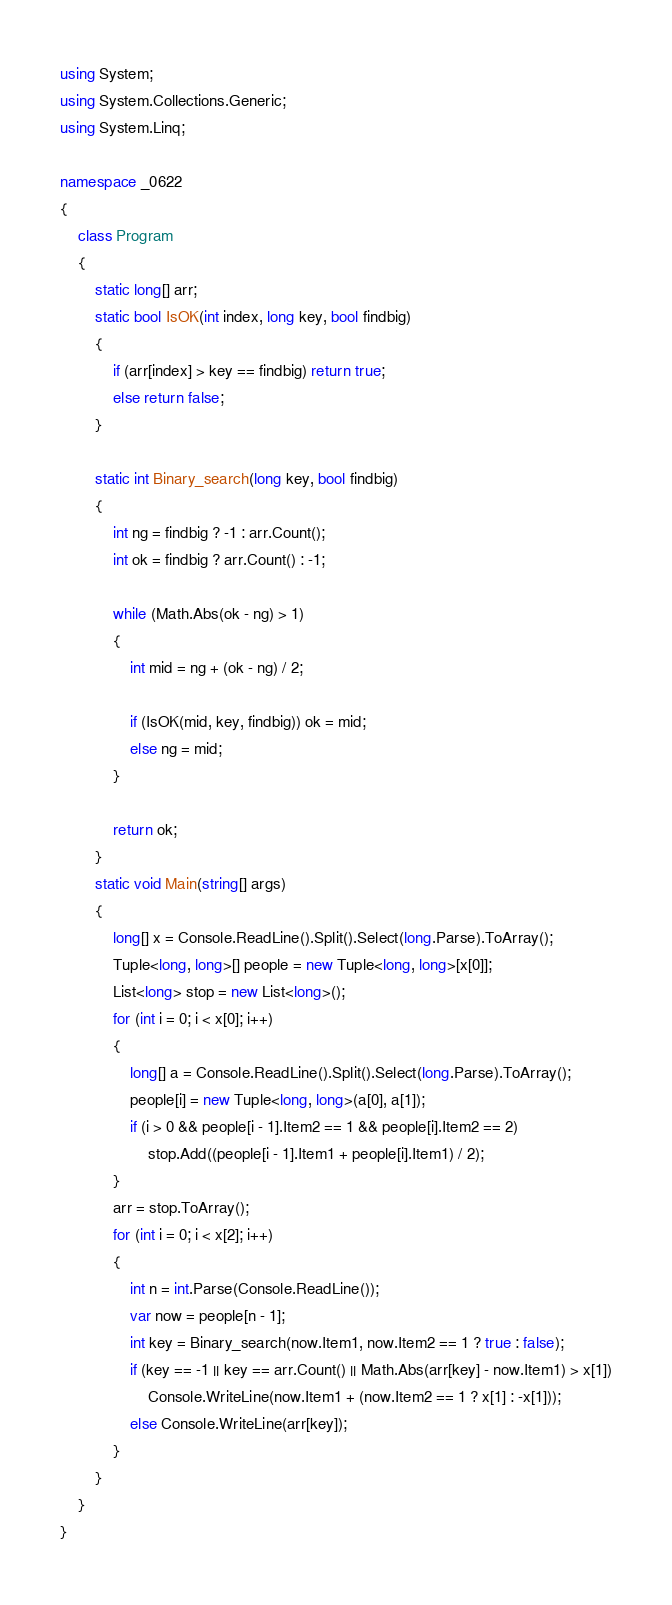Convert code to text. <code><loc_0><loc_0><loc_500><loc_500><_C#_>using System;
using System.Collections.Generic;
using System.Linq;

namespace _0622
{
	class Program
	{
		static long[] arr;
		static bool IsOK(int index, long key, bool findbig)
		{
			if (arr[index] > key == findbig) return true;
			else return false;
		}

		static int Binary_search(long key, bool findbig)
		{
			int ng = findbig ? -1 : arr.Count();
			int ok = findbig ? arr.Count() : -1;

			while (Math.Abs(ok - ng) > 1)
			{
				int mid = ng + (ok - ng) / 2;

				if (IsOK(mid, key, findbig)) ok = mid;
				else ng = mid;
			}

			return ok;
		}
		static void Main(string[] args)
		{
			long[] x = Console.ReadLine().Split().Select(long.Parse).ToArray();
			Tuple<long, long>[] people = new Tuple<long, long>[x[0]];
			List<long> stop = new List<long>();
			for (int i = 0; i < x[0]; i++)
			{
				long[] a = Console.ReadLine().Split().Select(long.Parse).ToArray();
				people[i] = new Tuple<long, long>(a[0], a[1]);
				if (i > 0 && people[i - 1].Item2 == 1 && people[i].Item2 == 2)
					stop.Add((people[i - 1].Item1 + people[i].Item1) / 2);
			}
			arr = stop.ToArray();
			for (int i = 0; i < x[2]; i++)
			{
				int n = int.Parse(Console.ReadLine());
				var now = people[n - 1];
				int key = Binary_search(now.Item1, now.Item2 == 1 ? true : false);
				if (key == -1 || key == arr.Count() || Math.Abs(arr[key] - now.Item1) > x[1])
					Console.WriteLine(now.Item1 + (now.Item2 == 1 ? x[1] : -x[1]));
				else Console.WriteLine(arr[key]);
			}
		}
	}
}
</code> 